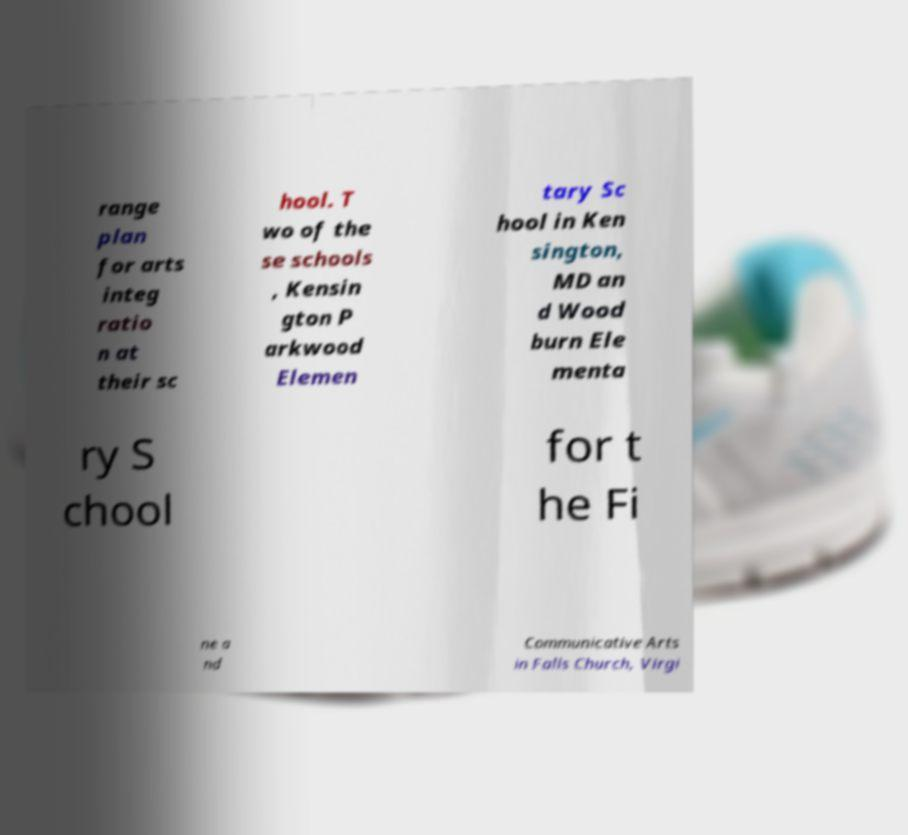There's text embedded in this image that I need extracted. Can you transcribe it verbatim? range plan for arts integ ratio n at their sc hool. T wo of the se schools , Kensin gton P arkwood Elemen tary Sc hool in Ken sington, MD an d Wood burn Ele menta ry S chool for t he Fi ne a nd Communicative Arts in Falls Church, Virgi 